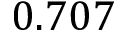<formula> <loc_0><loc_0><loc_500><loc_500>0 . 7 0 7</formula> 